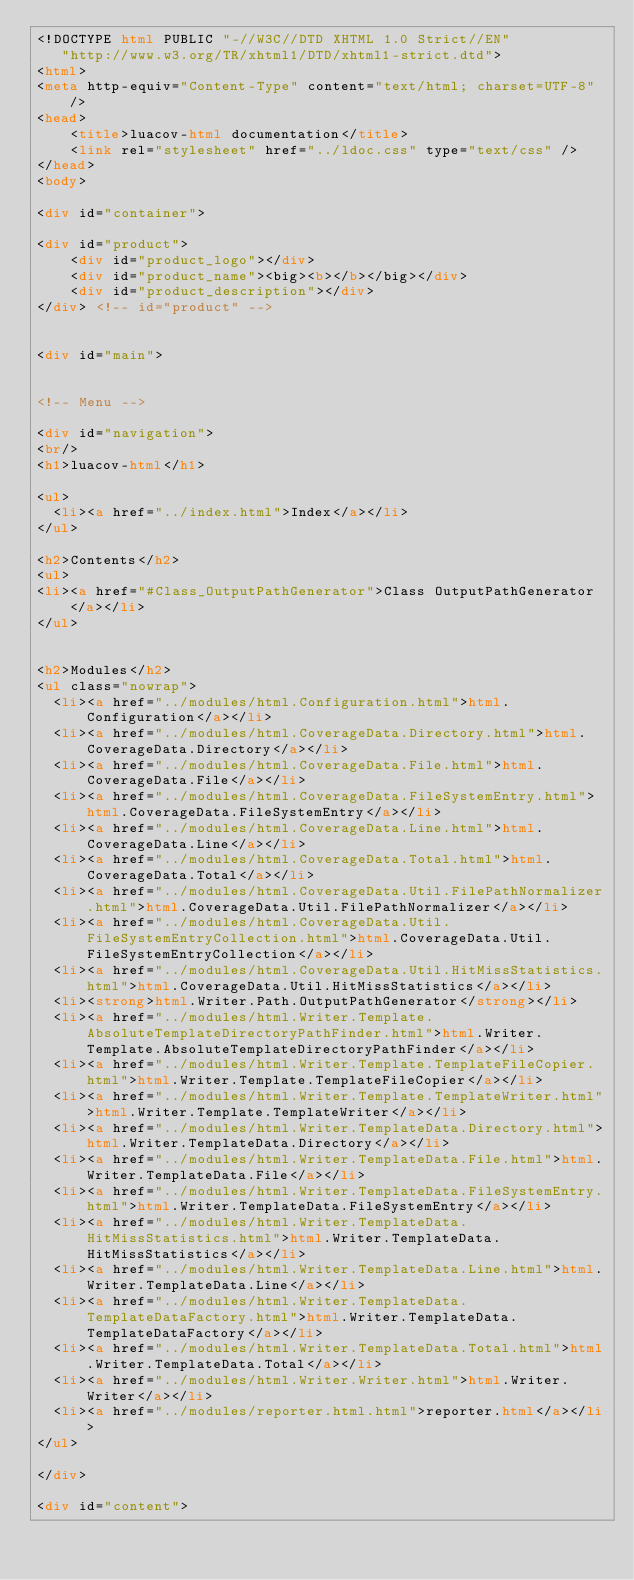<code> <loc_0><loc_0><loc_500><loc_500><_HTML_><!DOCTYPE html PUBLIC "-//W3C//DTD XHTML 1.0 Strict//EN"
   "http://www.w3.org/TR/xhtml1/DTD/xhtml1-strict.dtd">
<html>
<meta http-equiv="Content-Type" content="text/html; charset=UTF-8"/>
<head>
    <title>luacov-html documentation</title>
    <link rel="stylesheet" href="../ldoc.css" type="text/css" />
</head>
<body>

<div id="container">

<div id="product">
	<div id="product_logo"></div>
	<div id="product_name"><big><b></b></big></div>
	<div id="product_description"></div>
</div> <!-- id="product" -->


<div id="main">


<!-- Menu -->

<div id="navigation">
<br/>
<h1>luacov-html</h1>

<ul>
  <li><a href="../index.html">Index</a></li>
</ul>

<h2>Contents</h2>
<ul>
<li><a href="#Class_OutputPathGenerator">Class OutputPathGenerator </a></li>
</ul>


<h2>Modules</h2>
<ul class="nowrap">
  <li><a href="../modules/html.Configuration.html">html.Configuration</a></li>
  <li><a href="../modules/html.CoverageData.Directory.html">html.CoverageData.Directory</a></li>
  <li><a href="../modules/html.CoverageData.File.html">html.CoverageData.File</a></li>
  <li><a href="../modules/html.CoverageData.FileSystemEntry.html">html.CoverageData.FileSystemEntry</a></li>
  <li><a href="../modules/html.CoverageData.Line.html">html.CoverageData.Line</a></li>
  <li><a href="../modules/html.CoverageData.Total.html">html.CoverageData.Total</a></li>
  <li><a href="../modules/html.CoverageData.Util.FilePathNormalizer.html">html.CoverageData.Util.FilePathNormalizer</a></li>
  <li><a href="../modules/html.CoverageData.Util.FileSystemEntryCollection.html">html.CoverageData.Util.FileSystemEntryCollection</a></li>
  <li><a href="../modules/html.CoverageData.Util.HitMissStatistics.html">html.CoverageData.Util.HitMissStatistics</a></li>
  <li><strong>html.Writer.Path.OutputPathGenerator</strong></li>
  <li><a href="../modules/html.Writer.Template.AbsoluteTemplateDirectoryPathFinder.html">html.Writer.Template.AbsoluteTemplateDirectoryPathFinder</a></li>
  <li><a href="../modules/html.Writer.Template.TemplateFileCopier.html">html.Writer.Template.TemplateFileCopier</a></li>
  <li><a href="../modules/html.Writer.Template.TemplateWriter.html">html.Writer.Template.TemplateWriter</a></li>
  <li><a href="../modules/html.Writer.TemplateData.Directory.html">html.Writer.TemplateData.Directory</a></li>
  <li><a href="../modules/html.Writer.TemplateData.File.html">html.Writer.TemplateData.File</a></li>
  <li><a href="../modules/html.Writer.TemplateData.FileSystemEntry.html">html.Writer.TemplateData.FileSystemEntry</a></li>
  <li><a href="../modules/html.Writer.TemplateData.HitMissStatistics.html">html.Writer.TemplateData.HitMissStatistics</a></li>
  <li><a href="../modules/html.Writer.TemplateData.Line.html">html.Writer.TemplateData.Line</a></li>
  <li><a href="../modules/html.Writer.TemplateData.TemplateDataFactory.html">html.Writer.TemplateData.TemplateDataFactory</a></li>
  <li><a href="../modules/html.Writer.TemplateData.Total.html">html.Writer.TemplateData.Total</a></li>
  <li><a href="../modules/html.Writer.Writer.html">html.Writer.Writer</a></li>
  <li><a href="../modules/reporter.html.html">reporter.html</a></li>
</ul>

</div>

<div id="content">
</code> 